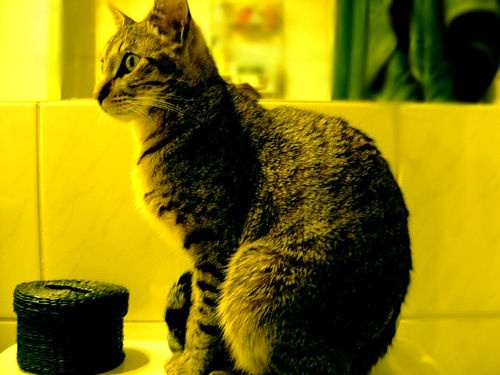Describe the objects in this image and their specific colors. I can see a cat in yellow, black, and olive tones in this image. 